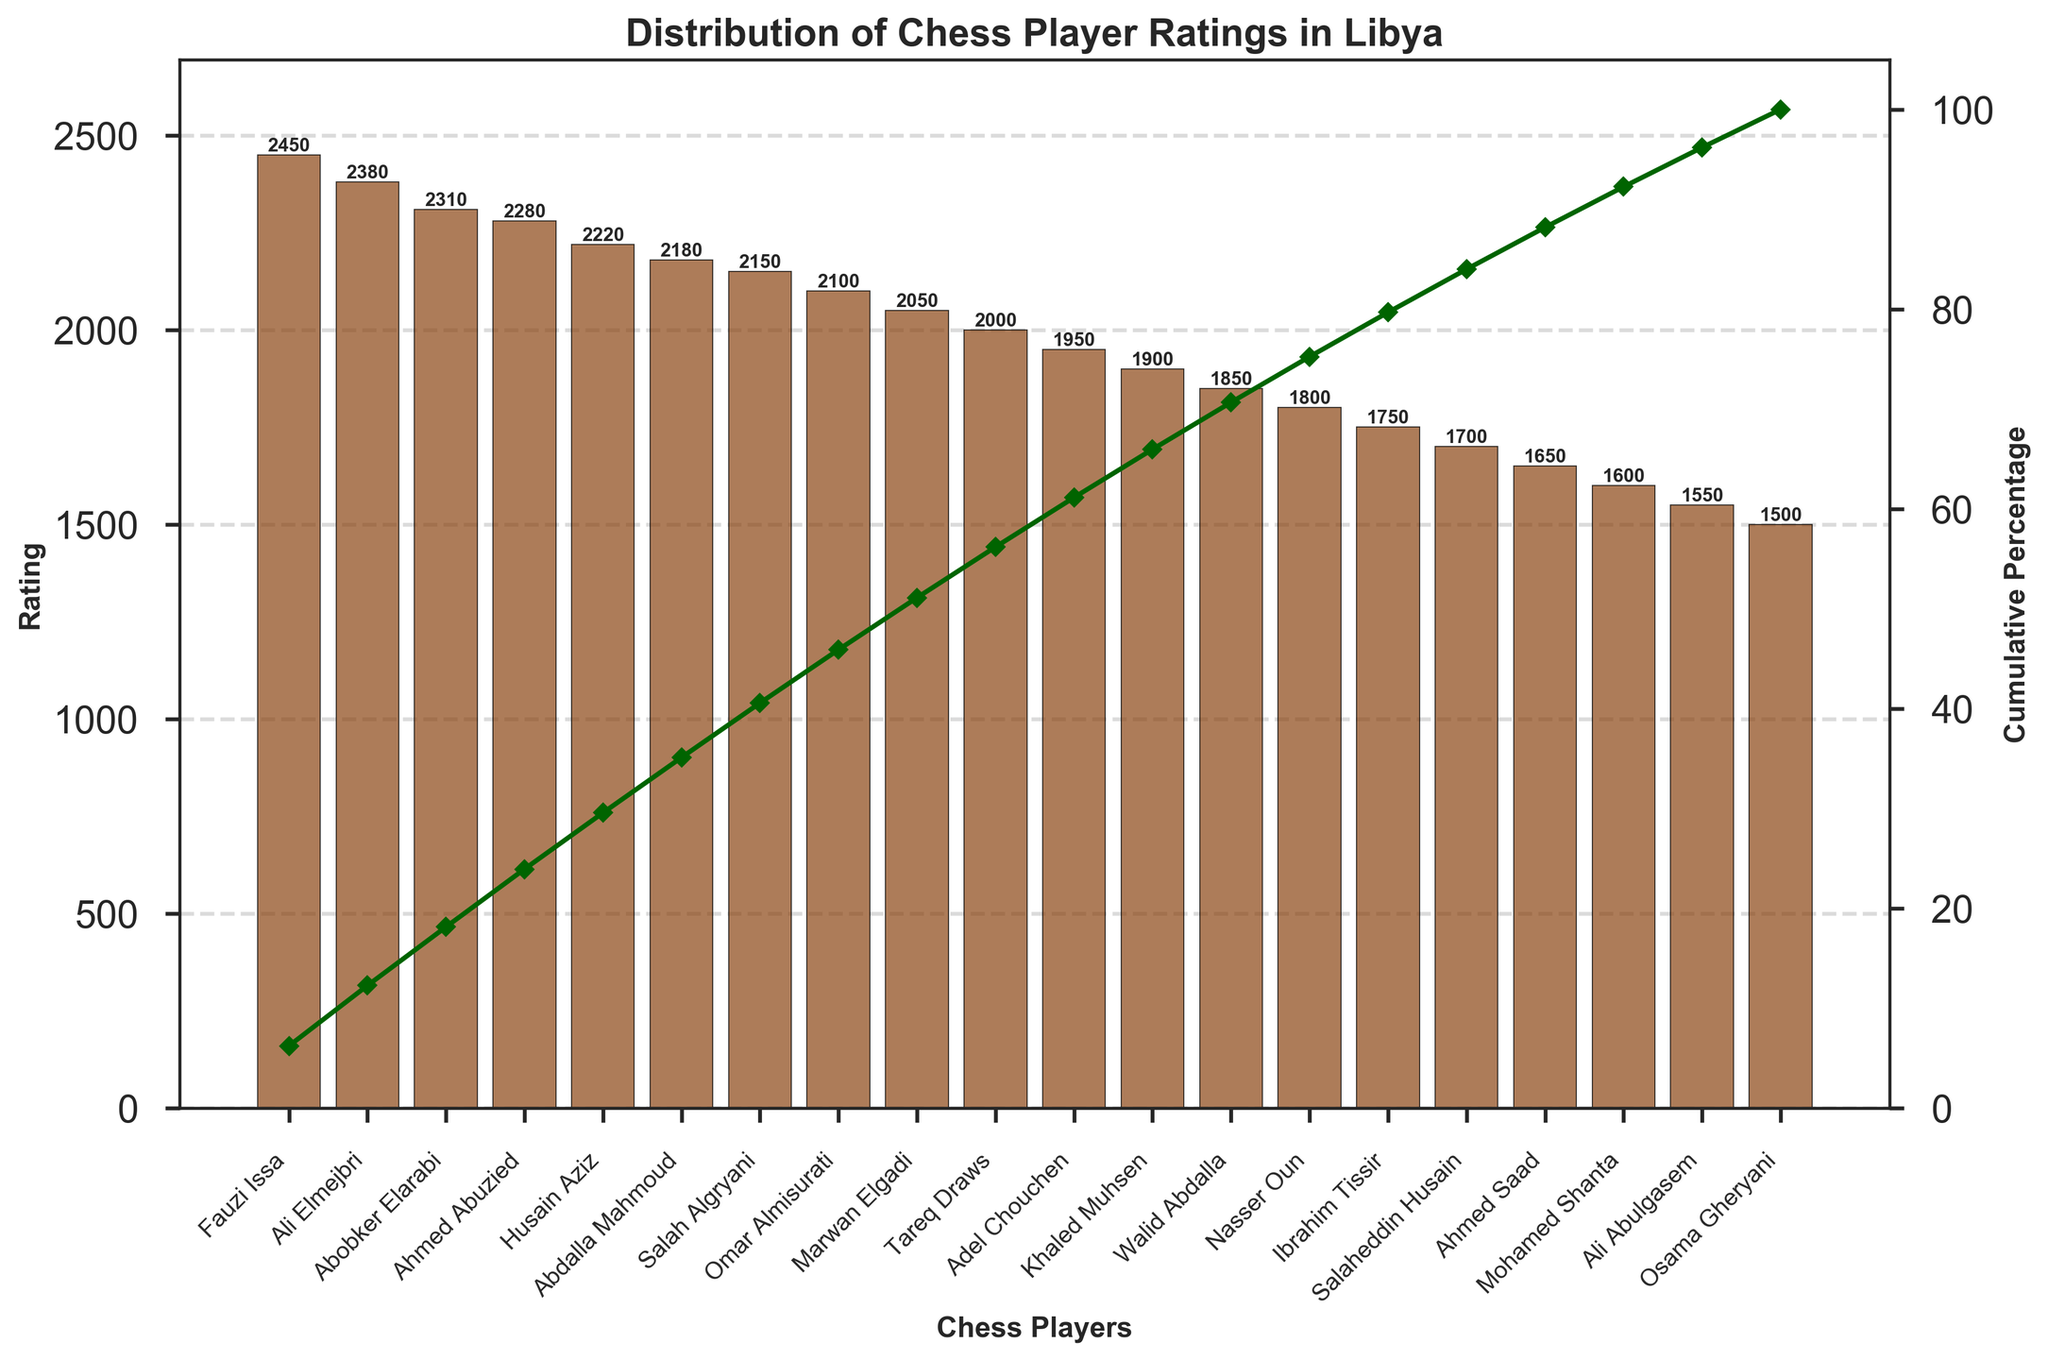Who is the highest-rated chess player in Libya according to the chart? The highest-rated chess player is the first bar on the left of the Pareto chart, with the tallest bar. The player's name is Fauzi Issa, and his rating is 2450.
Answer: Fauzi Issa What is the cumulative percentage when you reach the fourth highest-rated player? The cumulative percentage is visually indicated by the line plot that intersects the bar of the fourth player, which in this case is Ahmed Abuzied. At this point, the cumulative percentage is nearly 43%.
Answer: Nearly 43% What is the difference in rating between the highest and lowest-rated players? The rating of the highest-rated player, Fauzi Issa, is 2450, and the rating of the lowest-rated player, Osama Gheryani, is 1500. The difference is 2450 - 1500 = 950.
Answer: 950 How many players have a rating above 2100? All players whose ratings are above 2100 are represented by bars taller than the bar representing 2100 on the y-axis. These players are the first six on the left (Fauzi Issa, Ali Elmejbri, Abobker Elarabi, Ahmed Abuzied, Husain Aziz, and Abdalla Mahmoud).
Answer: 6 Which player reaches the 50% cumulative percentage mark? The cumulative percentage line crosses the 50% mark just after the bar representing Husain Aziz, and before Abdalla Mahmoud. Therefore, Husain Aziz is the player at this mark.
Answer: Husain Aziz What is the total rating sum of all chess players? The total rating sum is the sum of each player's rating. In the code, this sum is calculated before computing the cumulative percentage. By summing all the ratings: 2450 + 2380 + 2310 + 2280 + 2220 + 2180 + 2150 + 2100 + 2050 + 2000 + 1950 + 1900 + 1850 + 1800 + 1750 + 1700 + 1650 + 1600 + 1550 + 1500 = 40920.
Answer: 40920 What percentage of the total rating does the top 3 players' cumulative rating represent? The total rating for the top 3 players is 2450 + 2380 + 2310 = 7140. The overall total rating is 40920. Thus, the cumulative percentage is (7140 / 40920) * 100 = approximately 17.45%.
Answer: Approximately 17.45% What are the ratings of the top 5 players? The top five players, as derived from the sorted order of the bars, are Fauzi Issa, Ali Elmejbri, Abobker Elarabi, Ahmed Abuzied, and Husain Aziz. Their ratings are, respectively, 2450, 2380, 2310, 2280, and 2220.
Answer: 2450, 2380, 2310, 2280, 2220 